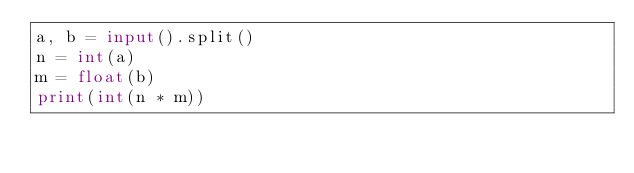Convert code to text. <code><loc_0><loc_0><loc_500><loc_500><_Python_>a, b = input().split()
n = int(a)
m = float(b)
print(int(n * m))</code> 